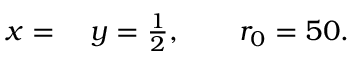Convert formula to latex. <formula><loc_0><loc_0><loc_500><loc_500>\begin{array} { r l } { x } & y = \frac { 1 } { 2 } , \quad r _ { 0 } = 5 0 . } \end{array}</formula> 